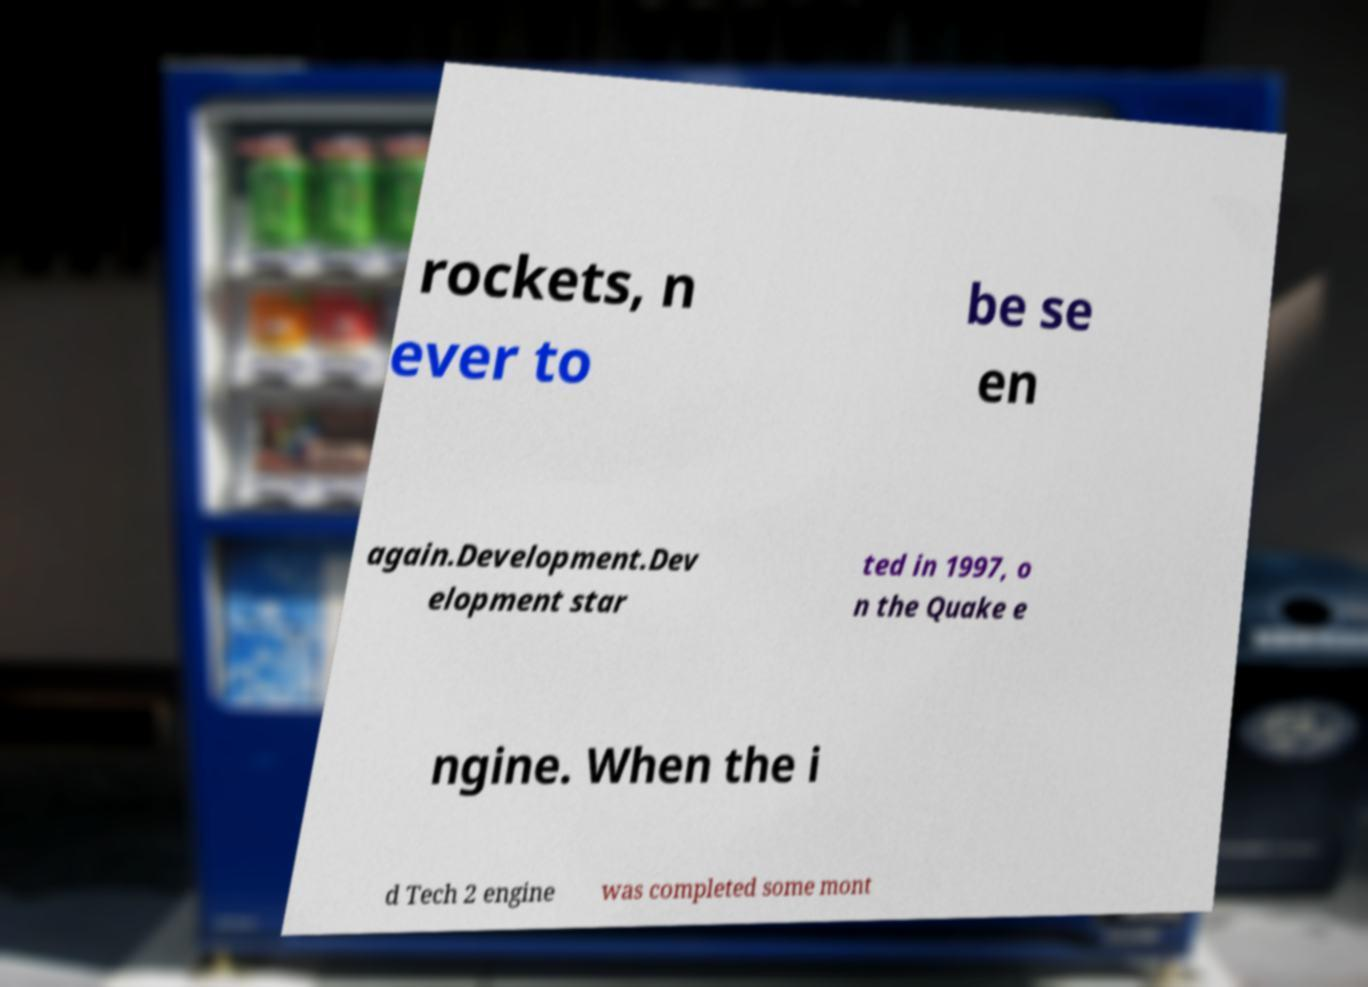Can you read and provide the text displayed in the image?This photo seems to have some interesting text. Can you extract and type it out for me? rockets, n ever to be se en again.Development.Dev elopment star ted in 1997, o n the Quake e ngine. When the i d Tech 2 engine was completed some mont 